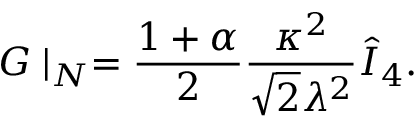<formula> <loc_0><loc_0><loc_500><loc_500>G | _ { N } = { \frac { 1 + \alpha } { 2 } } { \frac { \kappa ^ { 2 } } { \sqrt { 2 } \lambda ^ { 2 } } } \hat { I } _ { 4 } .</formula> 